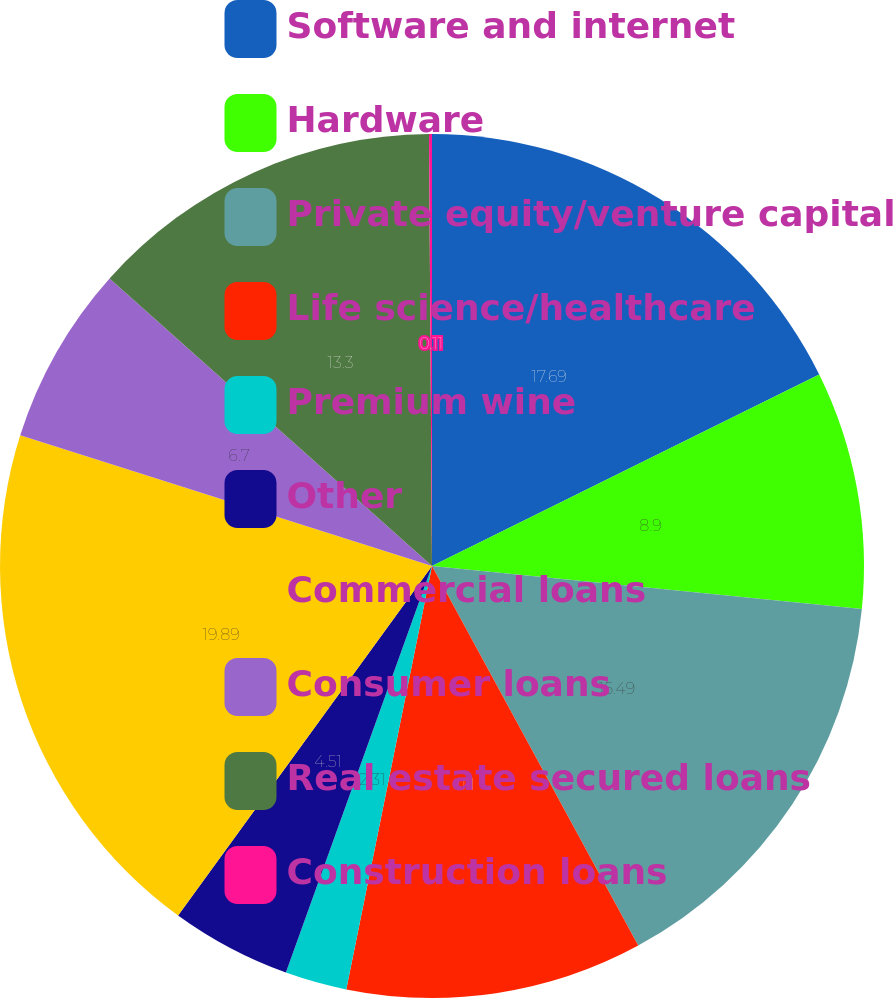<chart> <loc_0><loc_0><loc_500><loc_500><pie_chart><fcel>Software and internet<fcel>Hardware<fcel>Private equity/venture capital<fcel>Life science/healthcare<fcel>Premium wine<fcel>Other<fcel>Commercial loans<fcel>Consumer loans<fcel>Real estate secured loans<fcel>Construction loans<nl><fcel>17.69%<fcel>8.9%<fcel>15.49%<fcel>11.1%<fcel>2.31%<fcel>4.51%<fcel>19.89%<fcel>6.7%<fcel>13.3%<fcel>0.11%<nl></chart> 